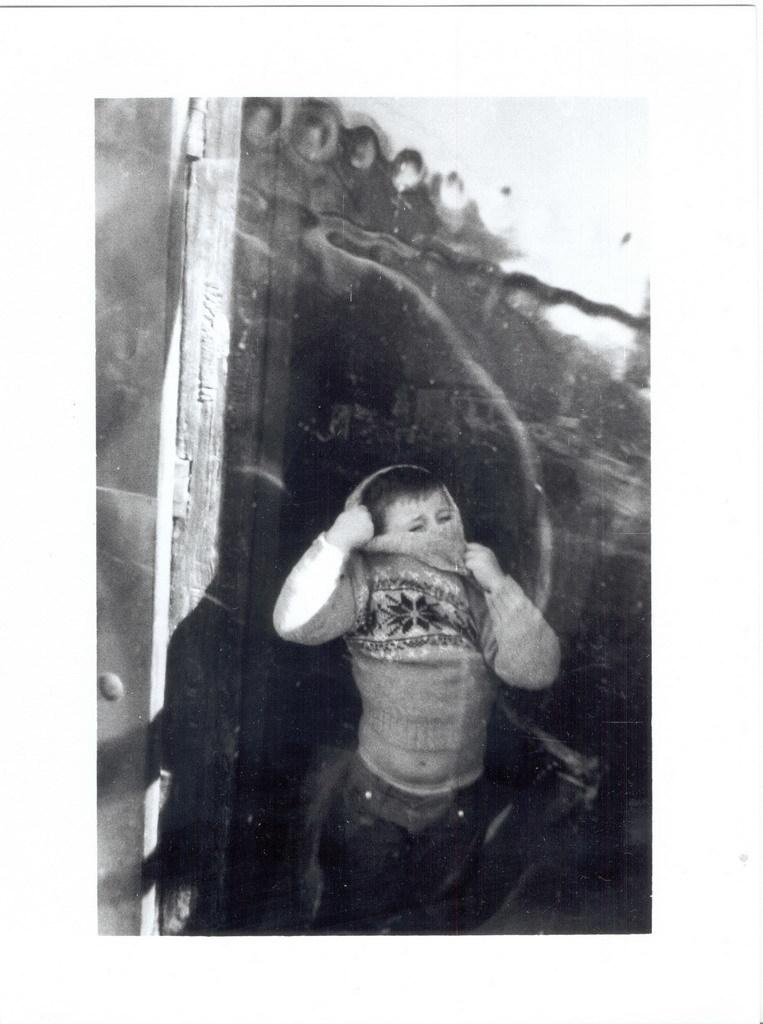What is the main subject of the image? The main subject of the image is a kid. What is the kid wearing in the image? The kid is wearing a sweater in the image. What can be seen in the background of the image? There is a wall in the background of the image. Can you describe any additional details about the background? Yes, there is a shadow on the wall in the background. What type of pleasure can be seen on the kid's face in the image? There is no indication of pleasure on the kid's face in the image, as no facial expression is mentioned in the provided facts. 